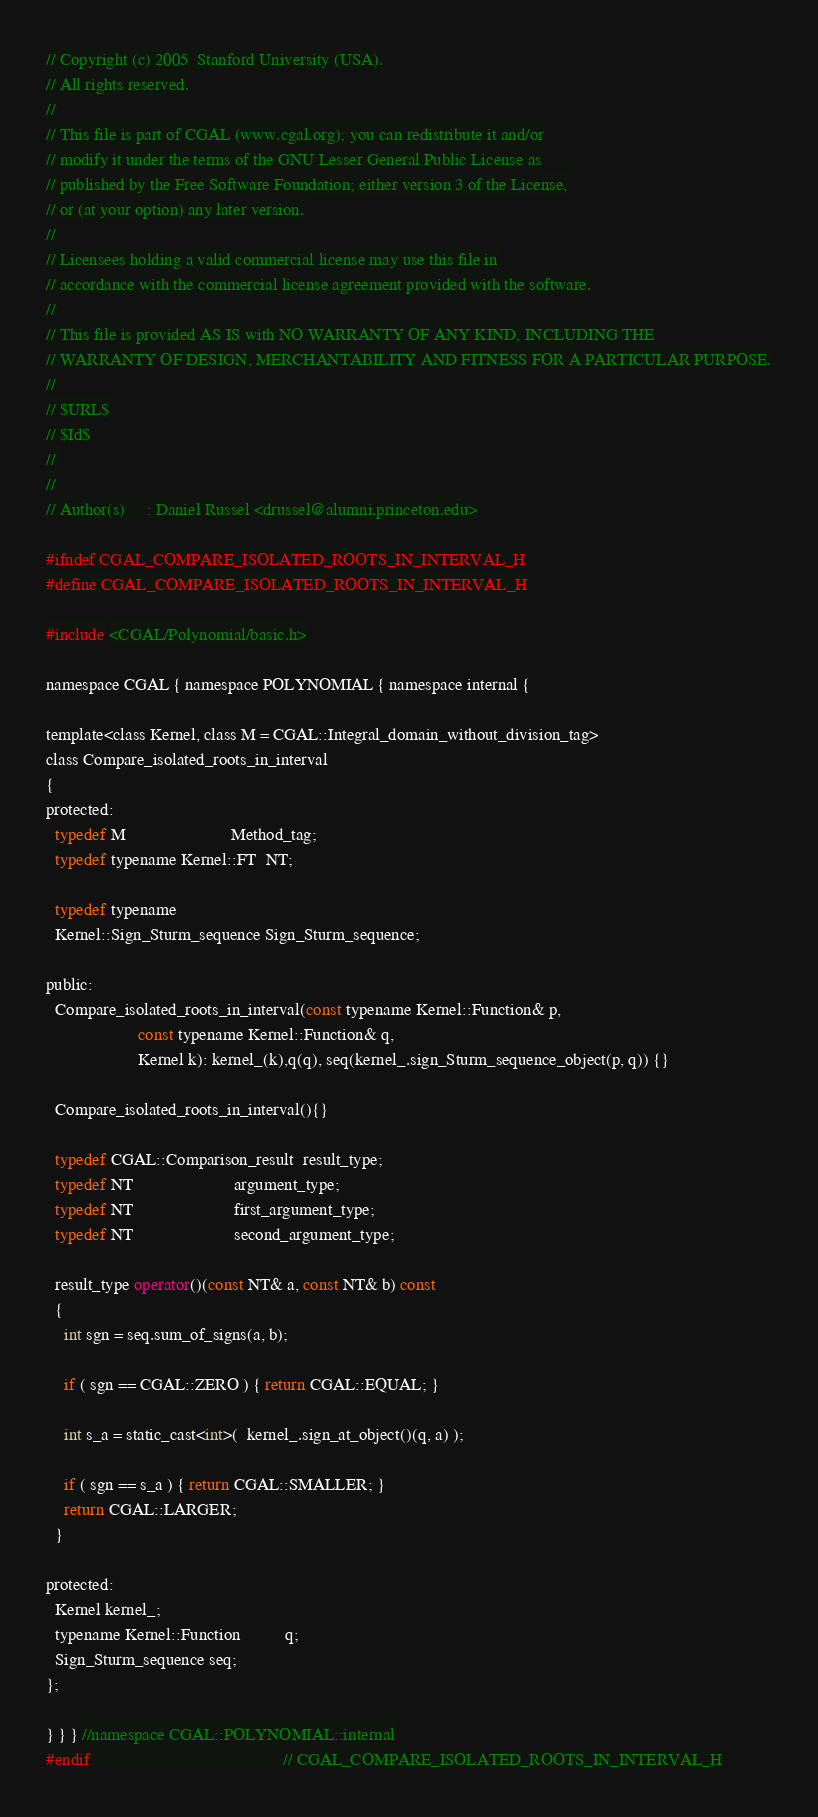<code> <loc_0><loc_0><loc_500><loc_500><_C_>// Copyright (c) 2005  Stanford University (USA).
// All rights reserved.
//
// This file is part of CGAL (www.cgal.org); you can redistribute it and/or
// modify it under the terms of the GNU Lesser General Public License as
// published by the Free Software Foundation; either version 3 of the License,
// or (at your option) any later version.
//
// Licensees holding a valid commercial license may use this file in
// accordance with the commercial license agreement provided with the software.
//
// This file is provided AS IS with NO WARRANTY OF ANY KIND, INCLUDING THE
// WARRANTY OF DESIGN, MERCHANTABILITY AND FITNESS FOR A PARTICULAR PURPOSE.
//
// $URL$
// $Id$
// 
//
// Author(s)     : Daniel Russel <drussel@alumni.princeton.edu>

#ifndef CGAL_COMPARE_ISOLATED_ROOTS_IN_INTERVAL_H
#define CGAL_COMPARE_ISOLATED_ROOTS_IN_INTERVAL_H

#include <CGAL/Polynomial/basic.h>

namespace CGAL { namespace POLYNOMIAL { namespace internal {

template<class Kernel, class M = CGAL::Integral_domain_without_division_tag>
class Compare_isolated_roots_in_interval
{
protected:
  typedef M                        Method_tag;
  typedef typename Kernel::FT  NT;

  typedef typename
  Kernel::Sign_Sturm_sequence Sign_Sturm_sequence;

public:
  Compare_isolated_roots_in_interval(const typename Kernel::Function& p,
				     const typename Kernel::Function& q,
				     Kernel k): kernel_(k),q(q), seq(kernel_.sign_Sturm_sequence_object(p, q)) {}

  Compare_isolated_roots_in_interval(){}

  typedef CGAL::Comparison_result  result_type;
  typedef NT                       argument_type;
  typedef NT                       first_argument_type;
  typedef NT                       second_argument_type;

  result_type operator()(const NT& a, const NT& b) const
  {
    int sgn = seq.sum_of_signs(a, b);

    if ( sgn == CGAL::ZERO ) { return CGAL::EQUAL; }

    int s_a = static_cast<int>(  kernel_.sign_at_object()(q, a) );

    if ( sgn == s_a ) { return CGAL::SMALLER; }
    return CGAL::LARGER;
  }

protected:
  Kernel kernel_;
  typename Kernel::Function          q;
  Sign_Sturm_sequence seq;
};

} } } //namespace CGAL::POLYNOMIAL::internal
#endif                                            // CGAL_COMPARE_ISOLATED_ROOTS_IN_INTERVAL_H
</code> 